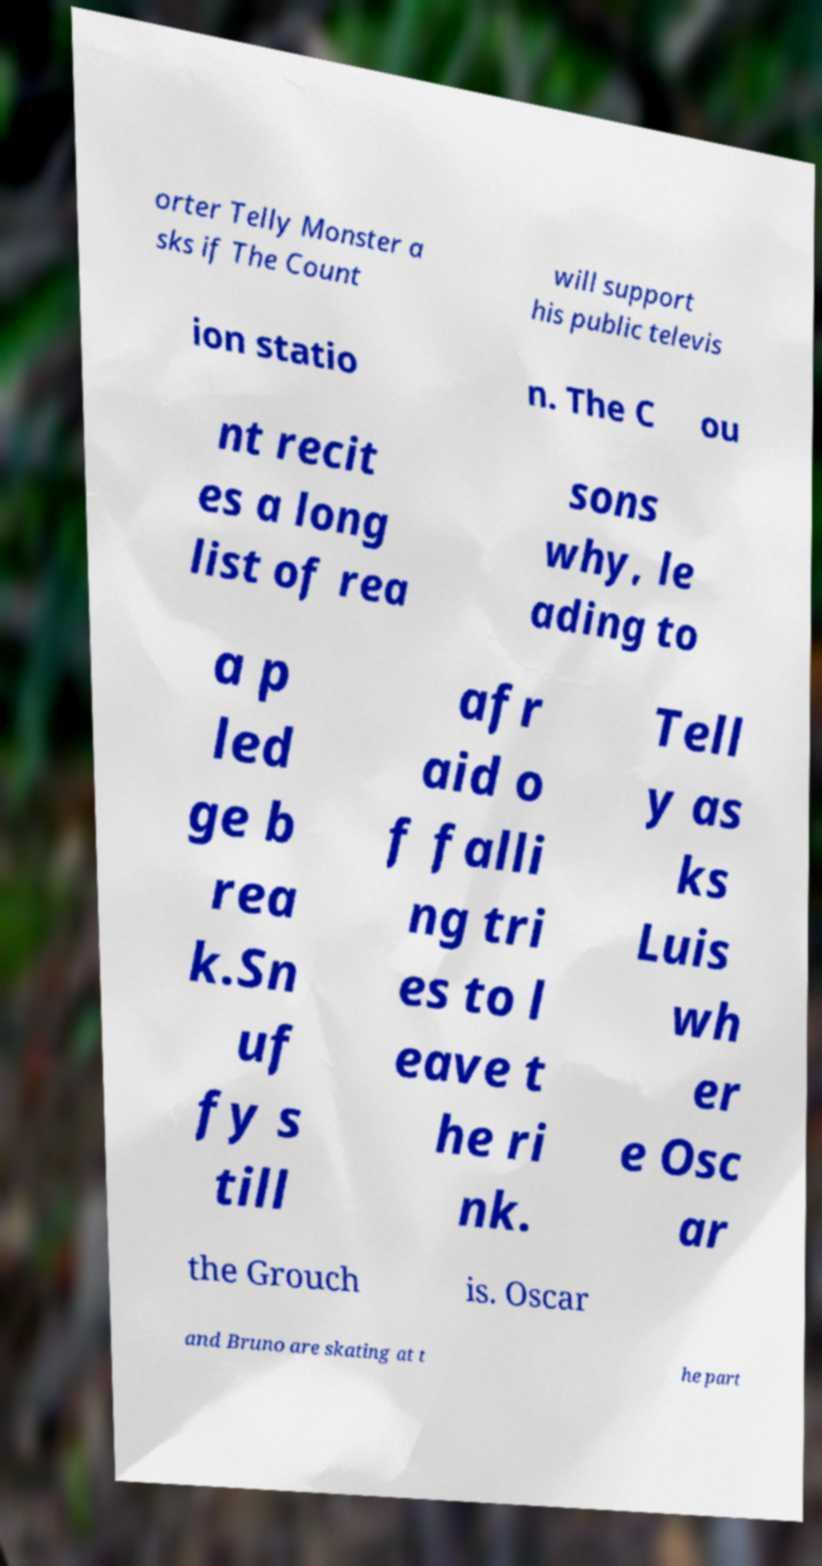Please identify and transcribe the text found in this image. orter Telly Monster a sks if The Count will support his public televis ion statio n. The C ou nt recit es a long list of rea sons why, le ading to a p led ge b rea k.Sn uf fy s till afr aid o f falli ng tri es to l eave t he ri nk. Tell y as ks Luis wh er e Osc ar the Grouch is. Oscar and Bruno are skating at t he part 